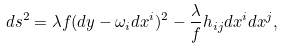Convert formula to latex. <formula><loc_0><loc_0><loc_500><loc_500>d s ^ { 2 } = \lambda f ( d y - \omega _ { i } d x ^ { i } ) ^ { 2 } - \frac { \lambda } { f } h _ { i j } d x ^ { i } d x ^ { j } ,</formula> 